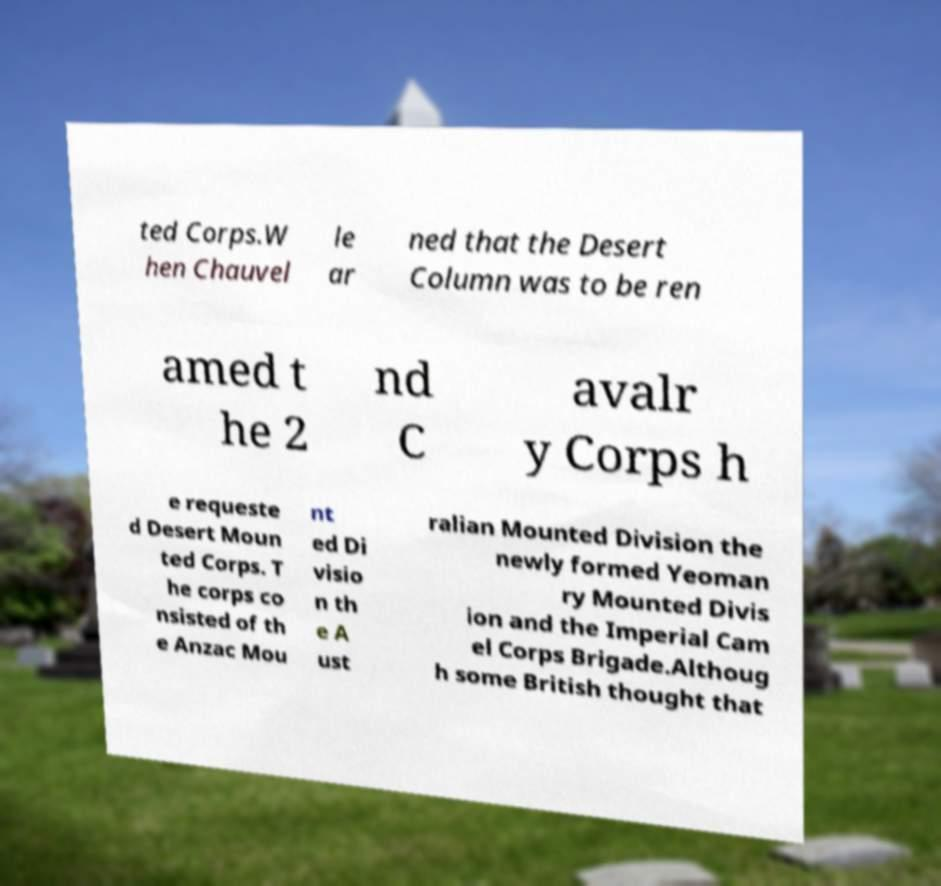Please identify and transcribe the text found in this image. ted Corps.W hen Chauvel le ar ned that the Desert Column was to be ren amed t he 2 nd C avalr y Corps h e requeste d Desert Moun ted Corps. T he corps co nsisted of th e Anzac Mou nt ed Di visio n th e A ust ralian Mounted Division the newly formed Yeoman ry Mounted Divis ion and the Imperial Cam el Corps Brigade.Althoug h some British thought that 